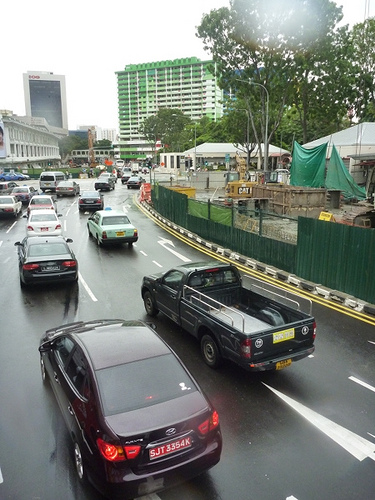<image>
Can you confirm if the tarp is behind the gate? Yes. From this viewpoint, the tarp is positioned behind the gate, with the gate partially or fully occluding the tarp. Is there a road in the car? No. The road is not contained within the car. These objects have a different spatial relationship. Is the car in front of the road? No. The car is not in front of the road. The spatial positioning shows a different relationship between these objects. 